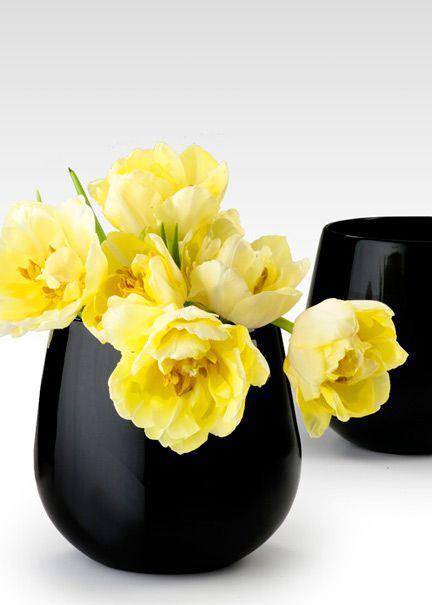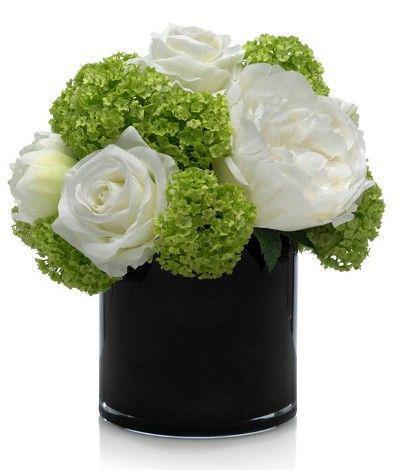The first image is the image on the left, the second image is the image on the right. Considering the images on both sides, is "A short black vase has red flowers." valid? Answer yes or no. No. The first image is the image on the left, the second image is the image on the right. Given the left and right images, does the statement "The right image contains white flowers in a black vase." hold true? Answer yes or no. Yes. 